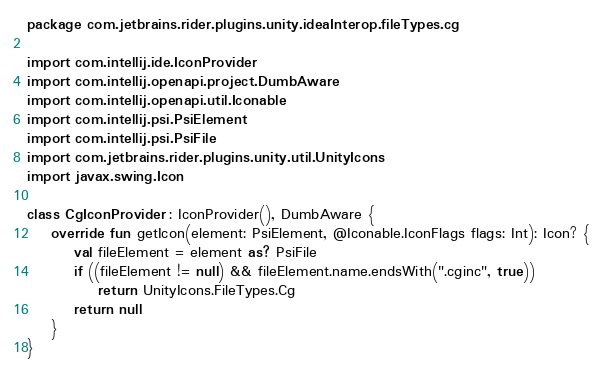<code> <loc_0><loc_0><loc_500><loc_500><_Kotlin_>package com.jetbrains.rider.plugins.unity.ideaInterop.fileTypes.cg

import com.intellij.ide.IconProvider
import com.intellij.openapi.project.DumbAware
import com.intellij.openapi.util.Iconable
import com.intellij.psi.PsiElement
import com.intellij.psi.PsiFile
import com.jetbrains.rider.plugins.unity.util.UnityIcons
import javax.swing.Icon

class CgIconProvider : IconProvider(), DumbAware {
    override fun getIcon(element: PsiElement, @Iconable.IconFlags flags: Int): Icon? {
        val fileElement = element as? PsiFile
        if ((fileElement != null) && fileElement.name.endsWith(".cginc", true))
            return UnityIcons.FileTypes.Cg
        return null
    }
}
</code> 